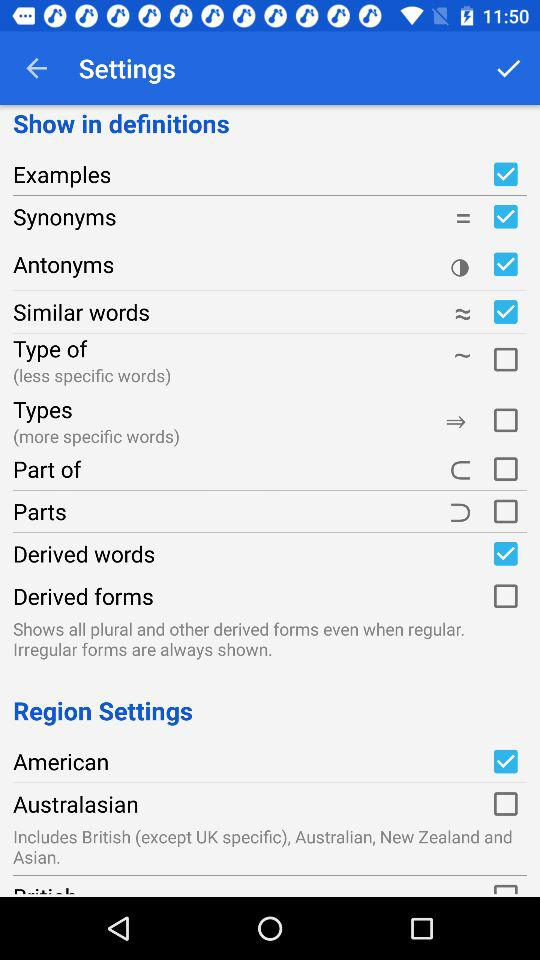What is "American" current status? The status is "on". 